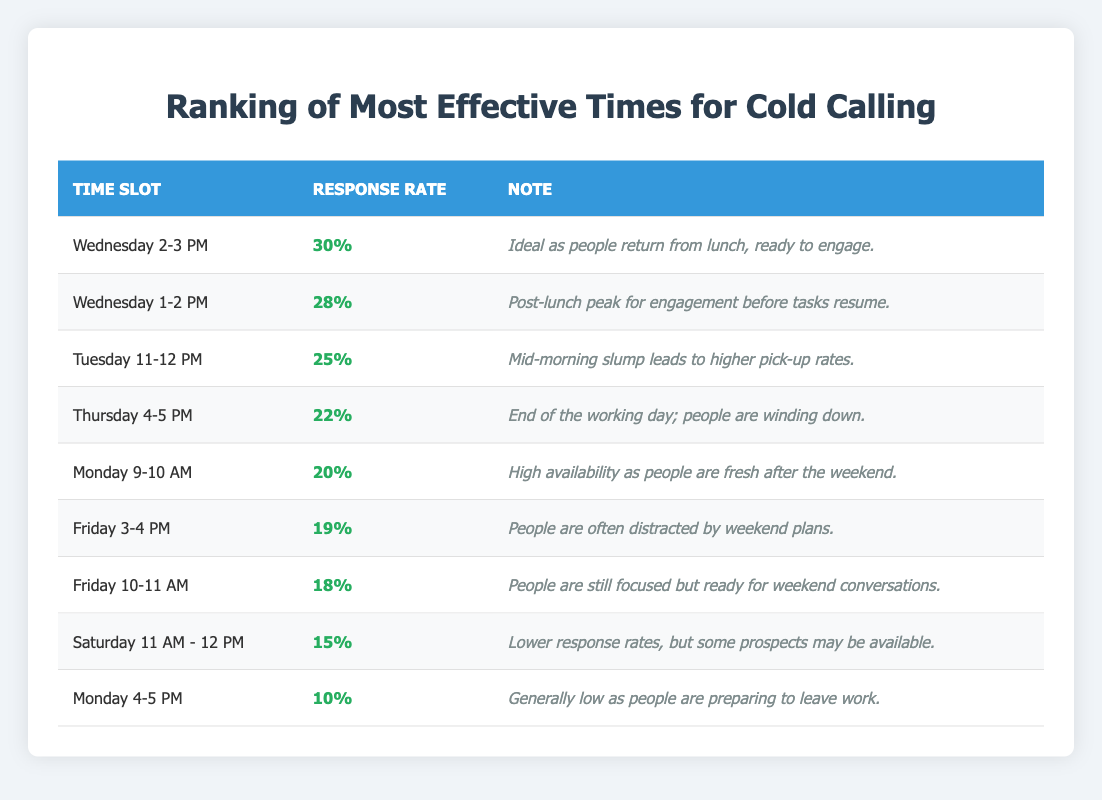What is the highest response rate percentage in the table? To find the highest response rate, I look through the "Response Rate" column. The highest value listed is 30%, corresponding to "Wednesday 2-3 PM."
Answer: 30% Which time slot has the lowest response rate? Scanning the "Response Rate" column, the lowest value is 10%, which is for "Monday 4-5 PM."
Answer: Monday 4-5 PM How many time slots have a response rate of 20% or higher? I count the time slots with response rates of 20% or more: "Monday 9-10 AM" (20%), "Tuesday 11-12 PM" (25%), "Wednesday 1-2 PM" (28%), "Wednesday 2-3 PM" (30%), "Thursday 4-5 PM" (22%). That totals to 5 slots.
Answer: 5 What is the average response rate of the top three time slots? The top three highest response rates are 30%, 28%, and 25%. To find the average, I sum them: 30 + 28 + 25 = 83. Then divide by 3: 83/3 ≈ 27.67%.
Answer: Approximately 27.67% Does "Saturday 11 AM - 12 PM" have a higher response rate than "Friday 10-11 AM"? I check the response rates: "Saturday 11 AM - 12 PM" is 15%, and "Friday 10-11 AM" is 18%. Since 15% is less than 18%, the statement is false.
Answer: No Which time slot is most effective for cold calling if I want to reach people after lunch? From the table, "Wednesday 2-3 PM" has the highest response rate at 30% and is right after lunch.
Answer: Wednesday 2-3 PM What is the difference in response rates between the best and the worst time slots? The best time slot is "Wednesday 2-3 PM" at 30%, and the worst is "Monday 4-5 PM" at 10%. The difference is 30 - 10 = 20%.
Answer: 20% Are there more time slots with a response rate above 20% or below 20%? I count the response rates: Above 20% are 5 slots ("Wednesday 2-3 PM," "Wednesday 1-2 PM," "Tuesday 11-12 PM," "Thursday 4-5 PM," "Monday 9-10 AM"). Below 20% are 4 slots. So, there are more above 20%.
Answer: More above 20% What is the average response rate for all time slots listed? I first sum all response rates: 30 + 28 + 25 + 22 + 20 + 19 + 18 + 15 + 10 =  187. Then divide by the number of time slots, which is 9: 187/9 ≈ 20.78%.
Answer: Approximately 20.78% Does "Thursday 4-5 PM" have a better response rate than "Friday 3-4 PM"? The response rate for "Thursday 4-5 PM" is 22%, while for "Friday 3-4 PM" it is 19%. Since 22% is greater than 19%, the statement is true.
Answer: Yes 